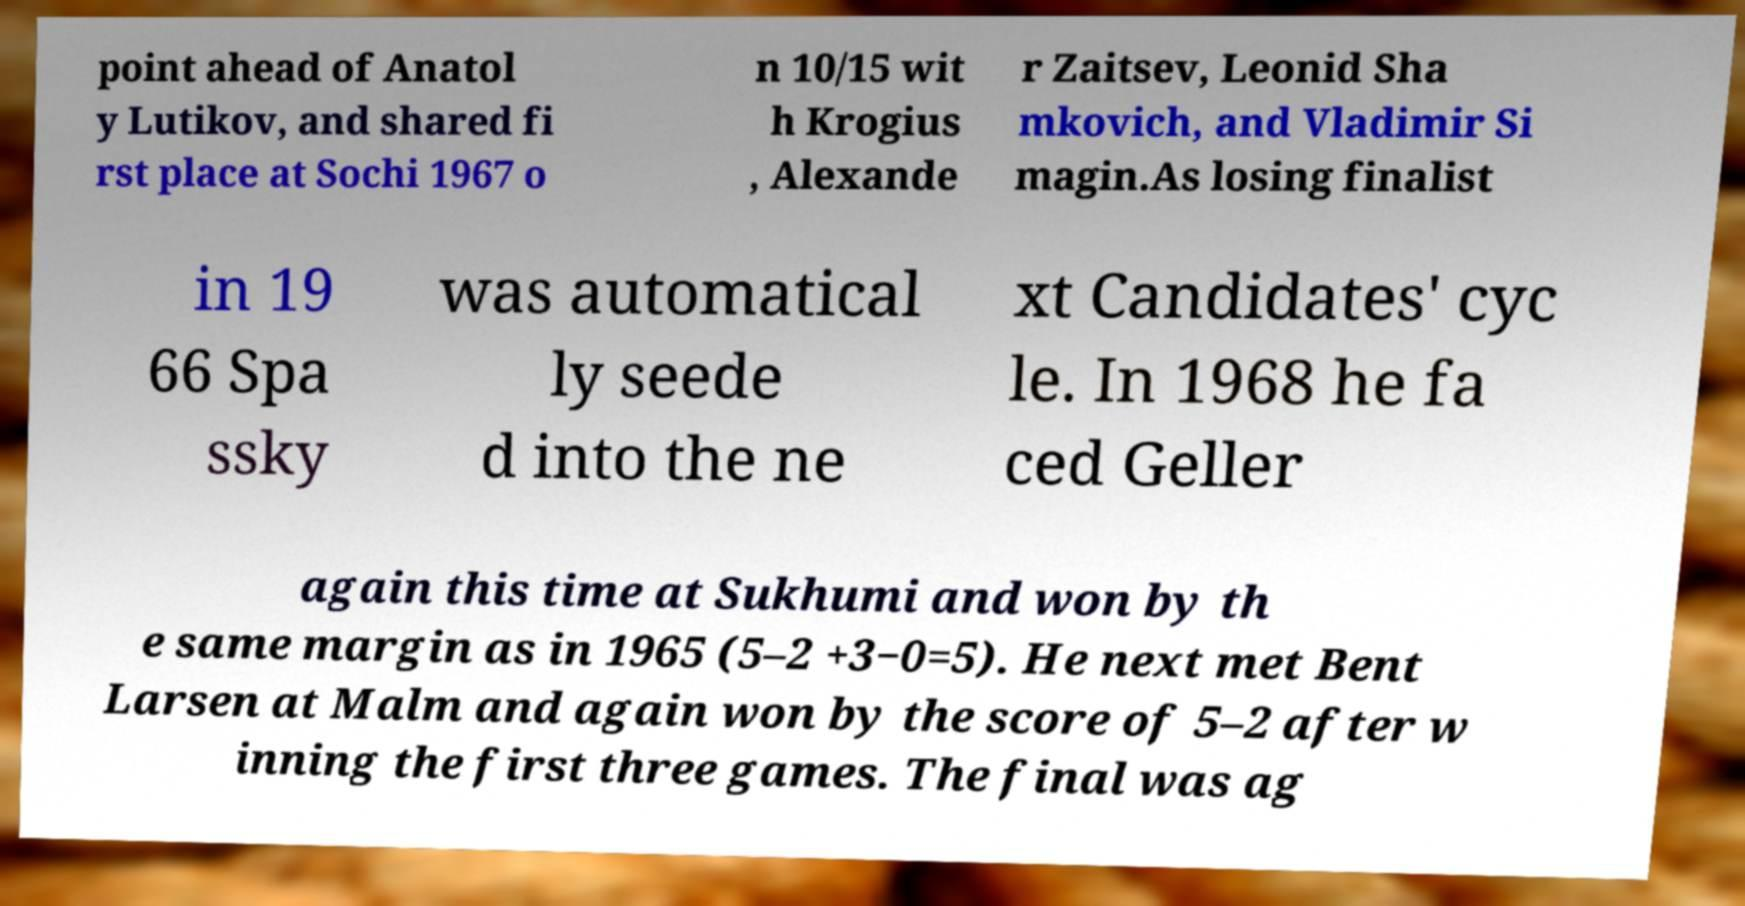There's text embedded in this image that I need extracted. Can you transcribe it verbatim? point ahead of Anatol y Lutikov, and shared fi rst place at Sochi 1967 o n 10/15 wit h Krogius , Alexande r Zaitsev, Leonid Sha mkovich, and Vladimir Si magin.As losing finalist in 19 66 Spa ssky was automatical ly seede d into the ne xt Candidates' cyc le. In 1968 he fa ced Geller again this time at Sukhumi and won by th e same margin as in 1965 (5–2 +3−0=5). He next met Bent Larsen at Malm and again won by the score of 5–2 after w inning the first three games. The final was ag 